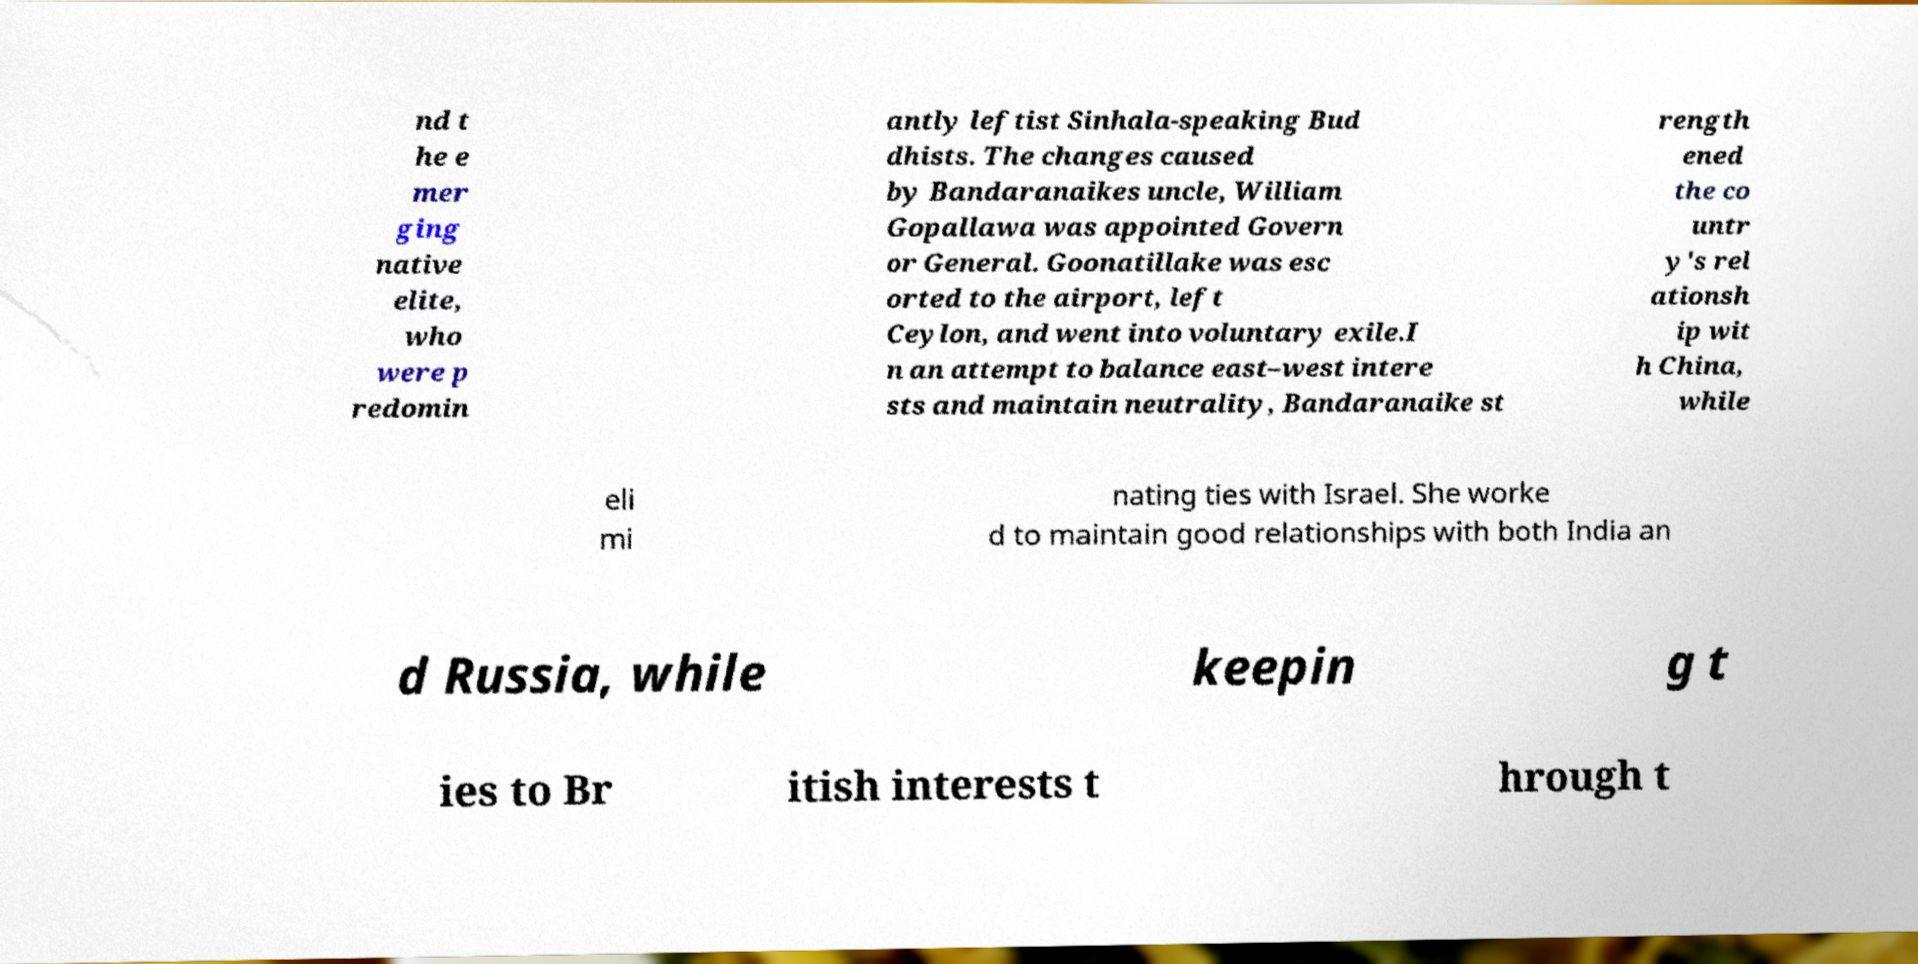I need the written content from this picture converted into text. Can you do that? nd t he e mer ging native elite, who were p redomin antly leftist Sinhala-speaking Bud dhists. The changes caused by Bandaranaikes uncle, William Gopallawa was appointed Govern or General. Goonatillake was esc orted to the airport, left Ceylon, and went into voluntary exile.I n an attempt to balance east–west intere sts and maintain neutrality, Bandaranaike st rength ened the co untr y's rel ationsh ip wit h China, while eli mi nating ties with Israel. She worke d to maintain good relationships with both India an d Russia, while keepin g t ies to Br itish interests t hrough t 